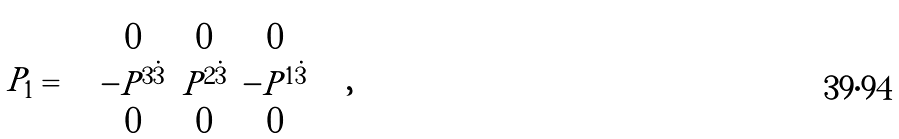Convert formula to latex. <formula><loc_0><loc_0><loc_500><loc_500>P _ { 1 } = \left ( \begin{array} { c c c } 0 & 0 & 0 \\ - P ^ { 3 \dot { 3 } } & P ^ { 2 \dot { 3 } } & - P ^ { 1 \dot { 3 } } \\ 0 & 0 & 0 \end{array} \right ) ,</formula> 